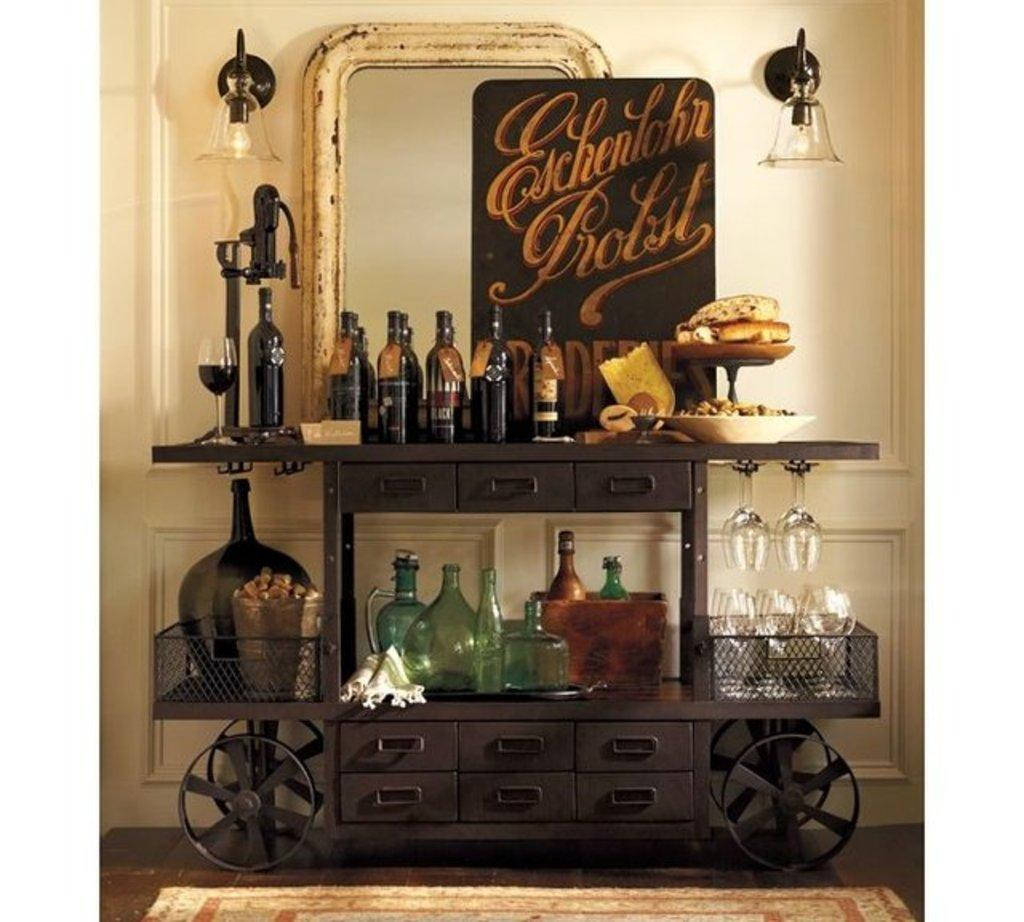<image>
Give a short and clear explanation of the subsequent image. A wine table has a poster that says Eschenlohn Brolst on it. 